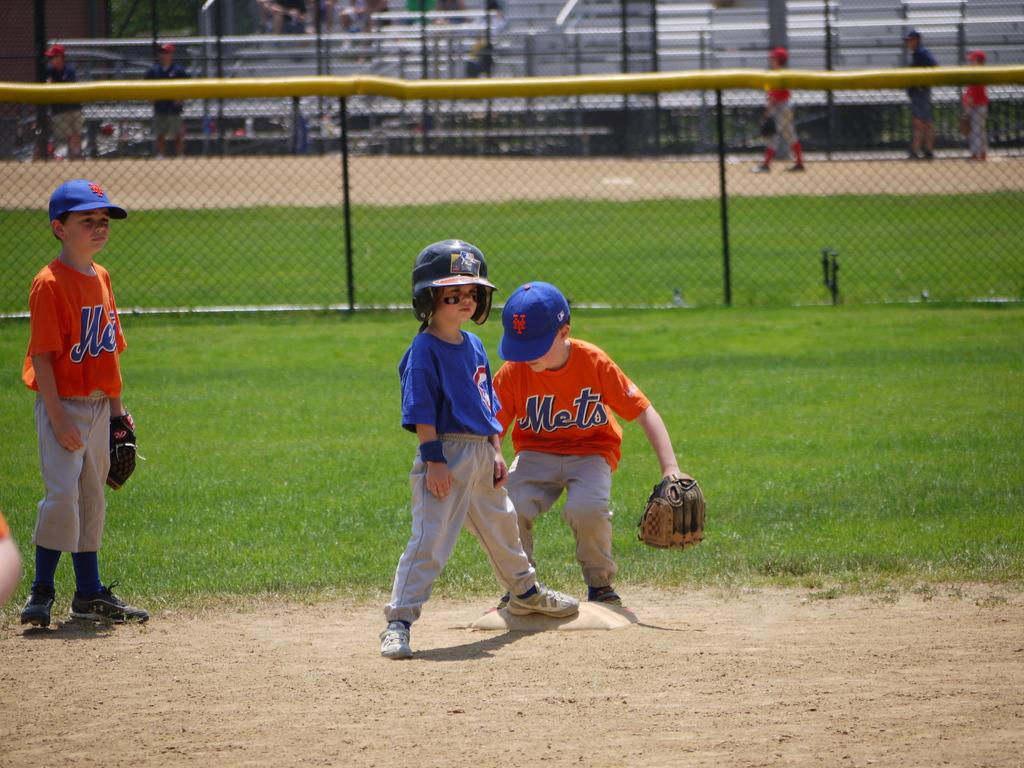<image>
Relay a brief, clear account of the picture shown. Three kids are playing ball, two of them have on Mets jerseys. 